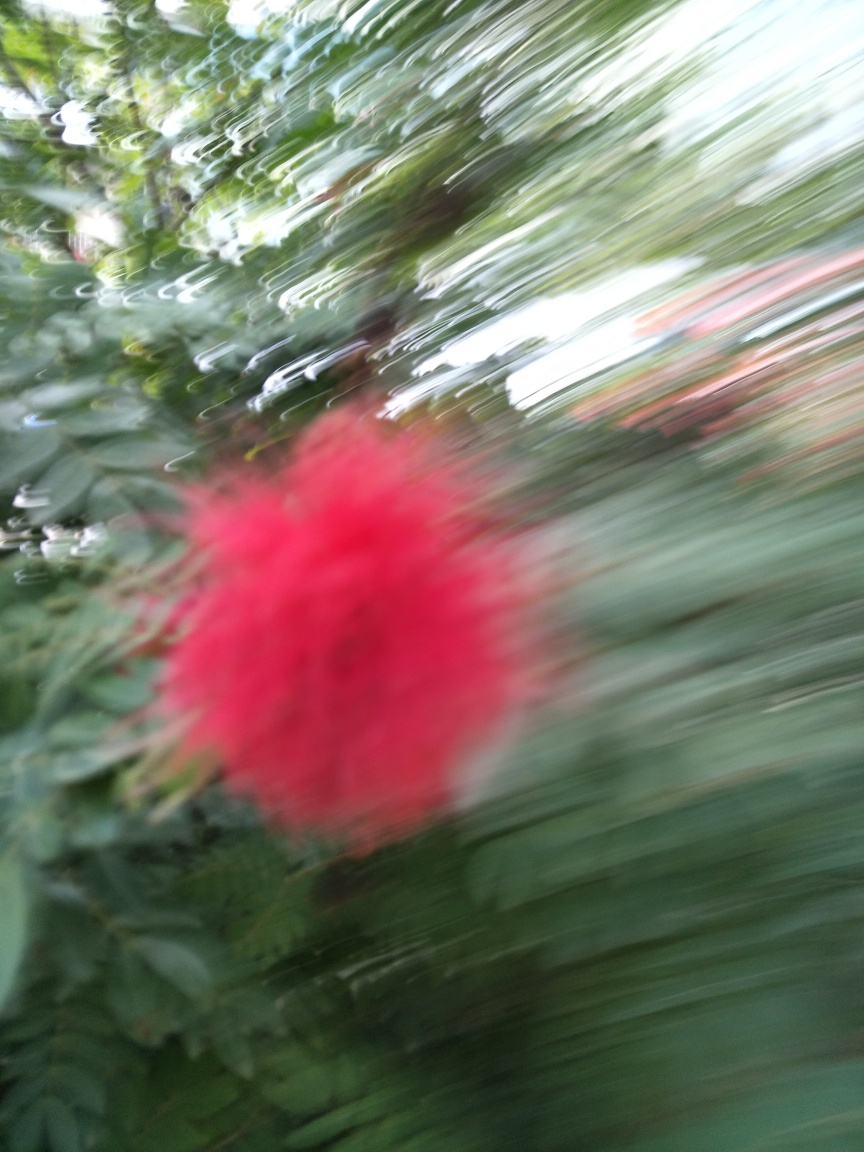What is the main subject in this photograph? The main subject seems to be a red flower, but due to the extensive blur, it's difficult to identify the type or details of the flower. 